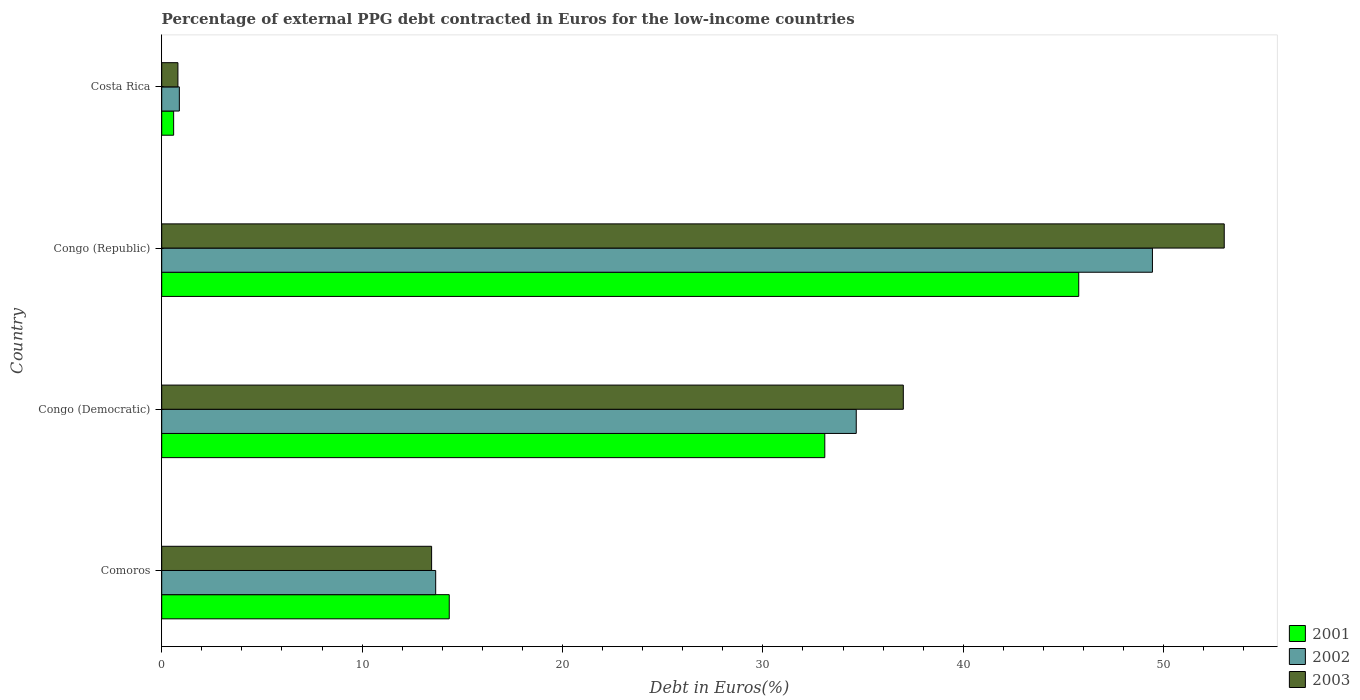How many different coloured bars are there?
Provide a succinct answer. 3. How many bars are there on the 4th tick from the top?
Provide a short and direct response. 3. How many bars are there on the 1st tick from the bottom?
Your response must be concise. 3. What is the label of the 3rd group of bars from the top?
Provide a succinct answer. Congo (Democratic). In how many cases, is the number of bars for a given country not equal to the number of legend labels?
Make the answer very short. 0. What is the percentage of external PPG debt contracted in Euros in 2003 in Congo (Republic)?
Your response must be concise. 53.02. Across all countries, what is the maximum percentage of external PPG debt contracted in Euros in 2003?
Your response must be concise. 53.02. Across all countries, what is the minimum percentage of external PPG debt contracted in Euros in 2001?
Your answer should be very brief. 0.6. In which country was the percentage of external PPG debt contracted in Euros in 2001 maximum?
Provide a succinct answer. Congo (Republic). What is the total percentage of external PPG debt contracted in Euros in 2003 in the graph?
Give a very brief answer. 104.31. What is the difference between the percentage of external PPG debt contracted in Euros in 2002 in Congo (Democratic) and that in Congo (Republic)?
Make the answer very short. -14.78. What is the difference between the percentage of external PPG debt contracted in Euros in 2002 in Costa Rica and the percentage of external PPG debt contracted in Euros in 2001 in Congo (Democratic)?
Offer a very short reply. -32.21. What is the average percentage of external PPG debt contracted in Euros in 2001 per country?
Give a very brief answer. 23.45. What is the difference between the percentage of external PPG debt contracted in Euros in 2001 and percentage of external PPG debt contracted in Euros in 2002 in Congo (Republic)?
Keep it short and to the point. -3.68. In how many countries, is the percentage of external PPG debt contracted in Euros in 2002 greater than 2 %?
Offer a very short reply. 3. What is the ratio of the percentage of external PPG debt contracted in Euros in 2003 in Congo (Democratic) to that in Costa Rica?
Offer a terse response. 45.76. Is the percentage of external PPG debt contracted in Euros in 2003 in Comoros less than that in Congo (Democratic)?
Offer a terse response. Yes. What is the difference between the highest and the second highest percentage of external PPG debt contracted in Euros in 2003?
Offer a terse response. 16.02. What is the difference between the highest and the lowest percentage of external PPG debt contracted in Euros in 2003?
Ensure brevity in your answer.  52.22. In how many countries, is the percentage of external PPG debt contracted in Euros in 2001 greater than the average percentage of external PPG debt contracted in Euros in 2001 taken over all countries?
Make the answer very short. 2. Are all the bars in the graph horizontal?
Provide a succinct answer. Yes. What is the difference between two consecutive major ticks on the X-axis?
Offer a very short reply. 10. Does the graph contain any zero values?
Your response must be concise. No. Does the graph contain grids?
Keep it short and to the point. No. What is the title of the graph?
Make the answer very short. Percentage of external PPG debt contracted in Euros for the low-income countries. Does "2010" appear as one of the legend labels in the graph?
Offer a terse response. No. What is the label or title of the X-axis?
Provide a succinct answer. Debt in Euros(%). What is the Debt in Euros(%) of 2001 in Comoros?
Provide a succinct answer. 14.35. What is the Debt in Euros(%) of 2002 in Comoros?
Ensure brevity in your answer.  13.67. What is the Debt in Euros(%) in 2003 in Comoros?
Your response must be concise. 13.47. What is the Debt in Euros(%) in 2001 in Congo (Democratic)?
Keep it short and to the point. 33.09. What is the Debt in Euros(%) in 2002 in Congo (Democratic)?
Your answer should be compact. 34.66. What is the Debt in Euros(%) in 2003 in Congo (Democratic)?
Offer a very short reply. 37.01. What is the Debt in Euros(%) of 2001 in Congo (Republic)?
Offer a terse response. 45.76. What is the Debt in Euros(%) of 2002 in Congo (Republic)?
Provide a succinct answer. 49.44. What is the Debt in Euros(%) in 2003 in Congo (Republic)?
Your answer should be compact. 53.02. What is the Debt in Euros(%) in 2001 in Costa Rica?
Make the answer very short. 0.6. What is the Debt in Euros(%) in 2003 in Costa Rica?
Provide a succinct answer. 0.81. Across all countries, what is the maximum Debt in Euros(%) in 2001?
Your answer should be very brief. 45.76. Across all countries, what is the maximum Debt in Euros(%) in 2002?
Keep it short and to the point. 49.44. Across all countries, what is the maximum Debt in Euros(%) of 2003?
Offer a terse response. 53.02. Across all countries, what is the minimum Debt in Euros(%) in 2001?
Your answer should be compact. 0.6. Across all countries, what is the minimum Debt in Euros(%) in 2003?
Offer a very short reply. 0.81. What is the total Debt in Euros(%) in 2001 in the graph?
Ensure brevity in your answer.  93.8. What is the total Debt in Euros(%) of 2002 in the graph?
Your answer should be compact. 98.65. What is the total Debt in Euros(%) in 2003 in the graph?
Your response must be concise. 104.31. What is the difference between the Debt in Euros(%) in 2001 in Comoros and that in Congo (Democratic)?
Offer a terse response. -18.74. What is the difference between the Debt in Euros(%) in 2002 in Comoros and that in Congo (Democratic)?
Provide a short and direct response. -20.99. What is the difference between the Debt in Euros(%) in 2003 in Comoros and that in Congo (Democratic)?
Your answer should be compact. -23.54. What is the difference between the Debt in Euros(%) of 2001 in Comoros and that in Congo (Republic)?
Offer a very short reply. -31.41. What is the difference between the Debt in Euros(%) of 2002 in Comoros and that in Congo (Republic)?
Ensure brevity in your answer.  -35.77. What is the difference between the Debt in Euros(%) in 2003 in Comoros and that in Congo (Republic)?
Give a very brief answer. -39.56. What is the difference between the Debt in Euros(%) of 2001 in Comoros and that in Costa Rica?
Your response must be concise. 13.75. What is the difference between the Debt in Euros(%) of 2002 in Comoros and that in Costa Rica?
Your answer should be very brief. 12.79. What is the difference between the Debt in Euros(%) of 2003 in Comoros and that in Costa Rica?
Offer a terse response. 12.66. What is the difference between the Debt in Euros(%) in 2001 in Congo (Democratic) and that in Congo (Republic)?
Make the answer very short. -12.67. What is the difference between the Debt in Euros(%) of 2002 in Congo (Democratic) and that in Congo (Republic)?
Provide a succinct answer. -14.78. What is the difference between the Debt in Euros(%) of 2003 in Congo (Democratic) and that in Congo (Republic)?
Your response must be concise. -16.02. What is the difference between the Debt in Euros(%) in 2001 in Congo (Democratic) and that in Costa Rica?
Keep it short and to the point. 32.5. What is the difference between the Debt in Euros(%) in 2002 in Congo (Democratic) and that in Costa Rica?
Keep it short and to the point. 33.78. What is the difference between the Debt in Euros(%) in 2003 in Congo (Democratic) and that in Costa Rica?
Your answer should be very brief. 36.2. What is the difference between the Debt in Euros(%) of 2001 in Congo (Republic) and that in Costa Rica?
Your answer should be compact. 45.17. What is the difference between the Debt in Euros(%) of 2002 in Congo (Republic) and that in Costa Rica?
Provide a short and direct response. 48.56. What is the difference between the Debt in Euros(%) in 2003 in Congo (Republic) and that in Costa Rica?
Your answer should be very brief. 52.22. What is the difference between the Debt in Euros(%) in 2001 in Comoros and the Debt in Euros(%) in 2002 in Congo (Democratic)?
Offer a terse response. -20.31. What is the difference between the Debt in Euros(%) of 2001 in Comoros and the Debt in Euros(%) of 2003 in Congo (Democratic)?
Your answer should be very brief. -22.66. What is the difference between the Debt in Euros(%) of 2002 in Comoros and the Debt in Euros(%) of 2003 in Congo (Democratic)?
Offer a terse response. -23.34. What is the difference between the Debt in Euros(%) of 2001 in Comoros and the Debt in Euros(%) of 2002 in Congo (Republic)?
Your response must be concise. -35.09. What is the difference between the Debt in Euros(%) in 2001 in Comoros and the Debt in Euros(%) in 2003 in Congo (Republic)?
Provide a short and direct response. -38.68. What is the difference between the Debt in Euros(%) in 2002 in Comoros and the Debt in Euros(%) in 2003 in Congo (Republic)?
Make the answer very short. -39.35. What is the difference between the Debt in Euros(%) in 2001 in Comoros and the Debt in Euros(%) in 2002 in Costa Rica?
Provide a short and direct response. 13.47. What is the difference between the Debt in Euros(%) of 2001 in Comoros and the Debt in Euros(%) of 2003 in Costa Rica?
Offer a very short reply. 13.54. What is the difference between the Debt in Euros(%) of 2002 in Comoros and the Debt in Euros(%) of 2003 in Costa Rica?
Ensure brevity in your answer.  12.86. What is the difference between the Debt in Euros(%) of 2001 in Congo (Democratic) and the Debt in Euros(%) of 2002 in Congo (Republic)?
Your response must be concise. -16.35. What is the difference between the Debt in Euros(%) in 2001 in Congo (Democratic) and the Debt in Euros(%) in 2003 in Congo (Republic)?
Keep it short and to the point. -19.93. What is the difference between the Debt in Euros(%) in 2002 in Congo (Democratic) and the Debt in Euros(%) in 2003 in Congo (Republic)?
Your answer should be compact. -18.36. What is the difference between the Debt in Euros(%) of 2001 in Congo (Democratic) and the Debt in Euros(%) of 2002 in Costa Rica?
Provide a short and direct response. 32.21. What is the difference between the Debt in Euros(%) in 2001 in Congo (Democratic) and the Debt in Euros(%) in 2003 in Costa Rica?
Keep it short and to the point. 32.28. What is the difference between the Debt in Euros(%) in 2002 in Congo (Democratic) and the Debt in Euros(%) in 2003 in Costa Rica?
Your answer should be compact. 33.85. What is the difference between the Debt in Euros(%) in 2001 in Congo (Republic) and the Debt in Euros(%) in 2002 in Costa Rica?
Give a very brief answer. 44.88. What is the difference between the Debt in Euros(%) of 2001 in Congo (Republic) and the Debt in Euros(%) of 2003 in Costa Rica?
Your response must be concise. 44.95. What is the difference between the Debt in Euros(%) of 2002 in Congo (Republic) and the Debt in Euros(%) of 2003 in Costa Rica?
Make the answer very short. 48.63. What is the average Debt in Euros(%) of 2001 per country?
Make the answer very short. 23.45. What is the average Debt in Euros(%) of 2002 per country?
Keep it short and to the point. 24.66. What is the average Debt in Euros(%) in 2003 per country?
Ensure brevity in your answer.  26.08. What is the difference between the Debt in Euros(%) in 2001 and Debt in Euros(%) in 2002 in Comoros?
Your answer should be very brief. 0.68. What is the difference between the Debt in Euros(%) of 2001 and Debt in Euros(%) of 2003 in Comoros?
Provide a succinct answer. 0.88. What is the difference between the Debt in Euros(%) in 2002 and Debt in Euros(%) in 2003 in Comoros?
Offer a terse response. 0.2. What is the difference between the Debt in Euros(%) in 2001 and Debt in Euros(%) in 2002 in Congo (Democratic)?
Offer a terse response. -1.57. What is the difference between the Debt in Euros(%) of 2001 and Debt in Euros(%) of 2003 in Congo (Democratic)?
Keep it short and to the point. -3.92. What is the difference between the Debt in Euros(%) of 2002 and Debt in Euros(%) of 2003 in Congo (Democratic)?
Your response must be concise. -2.35. What is the difference between the Debt in Euros(%) of 2001 and Debt in Euros(%) of 2002 in Congo (Republic)?
Offer a terse response. -3.68. What is the difference between the Debt in Euros(%) of 2001 and Debt in Euros(%) of 2003 in Congo (Republic)?
Provide a succinct answer. -7.26. What is the difference between the Debt in Euros(%) in 2002 and Debt in Euros(%) in 2003 in Congo (Republic)?
Give a very brief answer. -3.58. What is the difference between the Debt in Euros(%) in 2001 and Debt in Euros(%) in 2002 in Costa Rica?
Keep it short and to the point. -0.28. What is the difference between the Debt in Euros(%) of 2001 and Debt in Euros(%) of 2003 in Costa Rica?
Your answer should be very brief. -0.21. What is the difference between the Debt in Euros(%) in 2002 and Debt in Euros(%) in 2003 in Costa Rica?
Provide a succinct answer. 0.07. What is the ratio of the Debt in Euros(%) in 2001 in Comoros to that in Congo (Democratic)?
Keep it short and to the point. 0.43. What is the ratio of the Debt in Euros(%) of 2002 in Comoros to that in Congo (Democratic)?
Offer a terse response. 0.39. What is the ratio of the Debt in Euros(%) of 2003 in Comoros to that in Congo (Democratic)?
Provide a short and direct response. 0.36. What is the ratio of the Debt in Euros(%) of 2001 in Comoros to that in Congo (Republic)?
Your answer should be very brief. 0.31. What is the ratio of the Debt in Euros(%) of 2002 in Comoros to that in Congo (Republic)?
Provide a short and direct response. 0.28. What is the ratio of the Debt in Euros(%) in 2003 in Comoros to that in Congo (Republic)?
Ensure brevity in your answer.  0.25. What is the ratio of the Debt in Euros(%) of 2001 in Comoros to that in Costa Rica?
Provide a succinct answer. 24.1. What is the ratio of the Debt in Euros(%) in 2002 in Comoros to that in Costa Rica?
Offer a very short reply. 15.54. What is the ratio of the Debt in Euros(%) of 2003 in Comoros to that in Costa Rica?
Your response must be concise. 16.65. What is the ratio of the Debt in Euros(%) in 2001 in Congo (Democratic) to that in Congo (Republic)?
Give a very brief answer. 0.72. What is the ratio of the Debt in Euros(%) of 2002 in Congo (Democratic) to that in Congo (Republic)?
Your answer should be very brief. 0.7. What is the ratio of the Debt in Euros(%) of 2003 in Congo (Democratic) to that in Congo (Republic)?
Provide a succinct answer. 0.7. What is the ratio of the Debt in Euros(%) of 2001 in Congo (Democratic) to that in Costa Rica?
Offer a very short reply. 55.58. What is the ratio of the Debt in Euros(%) of 2002 in Congo (Democratic) to that in Costa Rica?
Your answer should be very brief. 39.39. What is the ratio of the Debt in Euros(%) of 2003 in Congo (Democratic) to that in Costa Rica?
Your answer should be very brief. 45.76. What is the ratio of the Debt in Euros(%) in 2001 in Congo (Republic) to that in Costa Rica?
Your answer should be very brief. 76.86. What is the ratio of the Debt in Euros(%) of 2002 in Congo (Republic) to that in Costa Rica?
Keep it short and to the point. 56.18. What is the ratio of the Debt in Euros(%) of 2003 in Congo (Republic) to that in Costa Rica?
Ensure brevity in your answer.  65.56. What is the difference between the highest and the second highest Debt in Euros(%) of 2001?
Offer a terse response. 12.67. What is the difference between the highest and the second highest Debt in Euros(%) in 2002?
Your response must be concise. 14.78. What is the difference between the highest and the second highest Debt in Euros(%) in 2003?
Keep it short and to the point. 16.02. What is the difference between the highest and the lowest Debt in Euros(%) in 2001?
Provide a short and direct response. 45.17. What is the difference between the highest and the lowest Debt in Euros(%) in 2002?
Keep it short and to the point. 48.56. What is the difference between the highest and the lowest Debt in Euros(%) in 2003?
Your response must be concise. 52.22. 